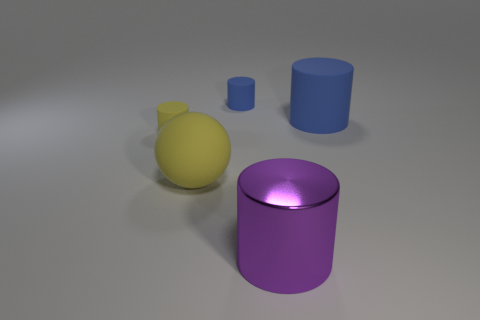How many small things are cylinders or brown spheres?
Your answer should be very brief. 2. What number of things are cylinders on the right side of the large purple cylinder or big matte cubes?
Provide a succinct answer. 1. What number of other objects are the same shape as the big purple metal object?
Make the answer very short. 3. How many brown objects are either cylinders or tiny rubber objects?
Your answer should be compact. 0. What is the color of the sphere that is the same material as the tiny yellow thing?
Make the answer very short. Yellow. Is the blue cylinder to the right of the shiny object made of the same material as the blue thing that is on the left side of the shiny object?
Provide a short and direct response. Yes. What is the size of the object that is the same color as the sphere?
Provide a short and direct response. Small. There is a small object that is to the right of the yellow rubber sphere; what material is it?
Your response must be concise. Rubber. There is a big matte thing that is to the left of the large blue cylinder; does it have the same shape as the blue object that is on the left side of the metallic cylinder?
Provide a succinct answer. No. There is a tiny cylinder that is the same color as the large ball; what material is it?
Your answer should be compact. Rubber. 